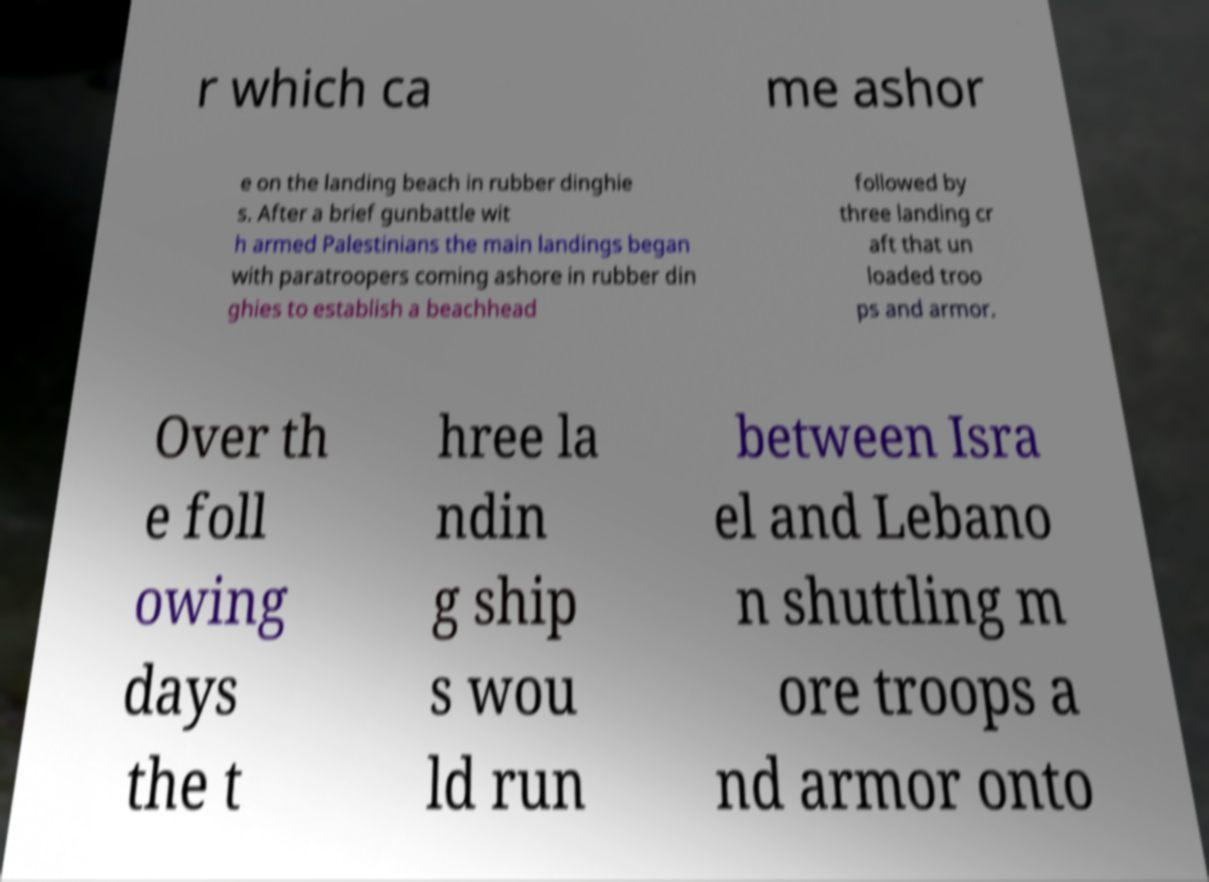Can you read and provide the text displayed in the image?This photo seems to have some interesting text. Can you extract and type it out for me? r which ca me ashor e on the landing beach in rubber dinghie s. After a brief gunbattle wit h armed Palestinians the main landings began with paratroopers coming ashore in rubber din ghies to establish a beachhead followed by three landing cr aft that un loaded troo ps and armor. Over th e foll owing days the t hree la ndin g ship s wou ld run between Isra el and Lebano n shuttling m ore troops a nd armor onto 